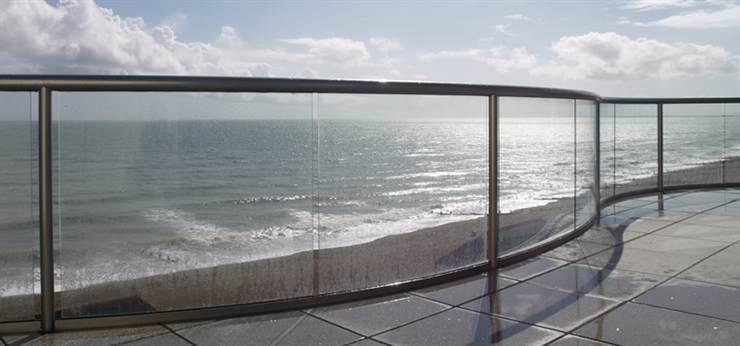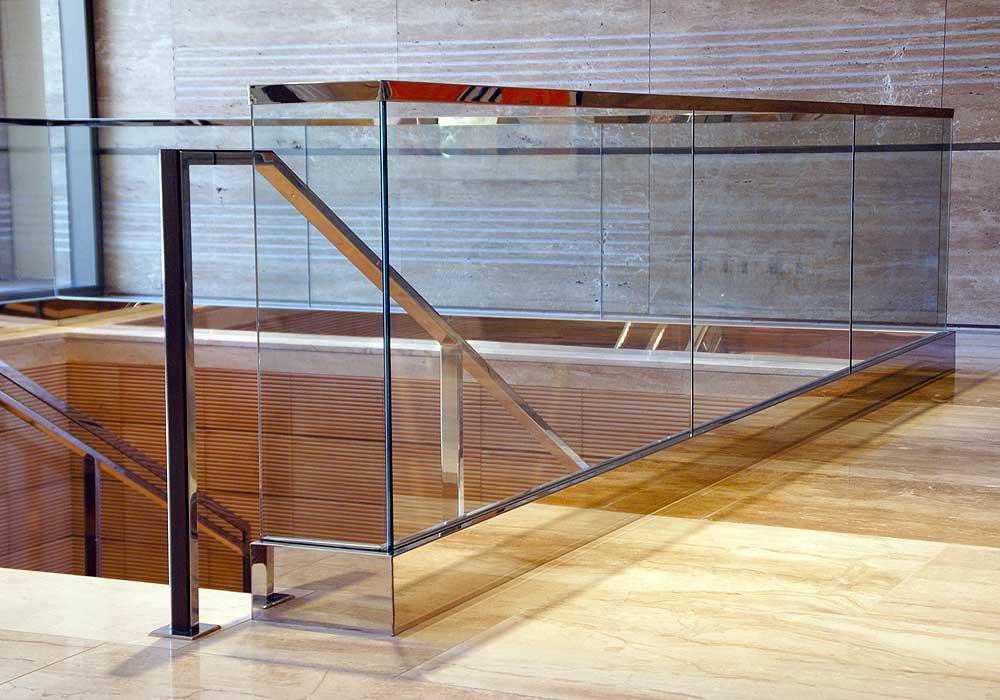The first image is the image on the left, the second image is the image on the right. Examine the images to the left and right. Is the description "In one image the sky and clouds are visible." accurate? Answer yes or no. Yes. The first image is the image on the left, the second image is the image on the right. For the images displayed, is the sentence "One image shows a glass-paneled balcony in a white building, and the other shows a glass-paneled staircase railing next to brown wood steps." factually correct? Answer yes or no. No. 